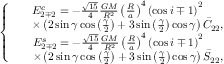<formula> <loc_0><loc_0><loc_500><loc_500>\left \{ \begin{array} { c } { \begin{array} { r l } & { E _ { 2 \mp 2 } ^ { c } = - \frac { \sqrt { 1 5 } } { 4 } \frac { G M } { R ^ { 2 } } \left ( \frac { R } { a } \right ) ^ { 4 } \left ( \cos i \mp 1 \right ) ^ { 2 } } \\ & { \times \left ( 2 \sin \gamma \cos \left ( \frac { \gamma } { 2 } \right ) + 3 \sin \left ( \frac { \gamma } { 2 } \right ) \cos \gamma \right ) \bar { C } _ { 2 2 } , } \end{array} } \\ { \begin{array} { r l } & { E _ { 2 \mp 2 } ^ { s } = - \frac { \sqrt { 1 5 } } { 4 } \frac { G M } { R ^ { 2 } } \left ( \frac { R } { a } \right ) ^ { 4 } \left ( \cos i \mp 1 \right ) ^ { 2 } } \\ & { \times \left ( 2 \sin \gamma \cos \left ( \frac { \gamma } { 2 } \right ) + 3 \sin \left ( \frac { \gamma } { 2 } \right ) \cos \gamma \right ) \bar { S } _ { 2 2 } , } \end{array} } \end{array}</formula> 